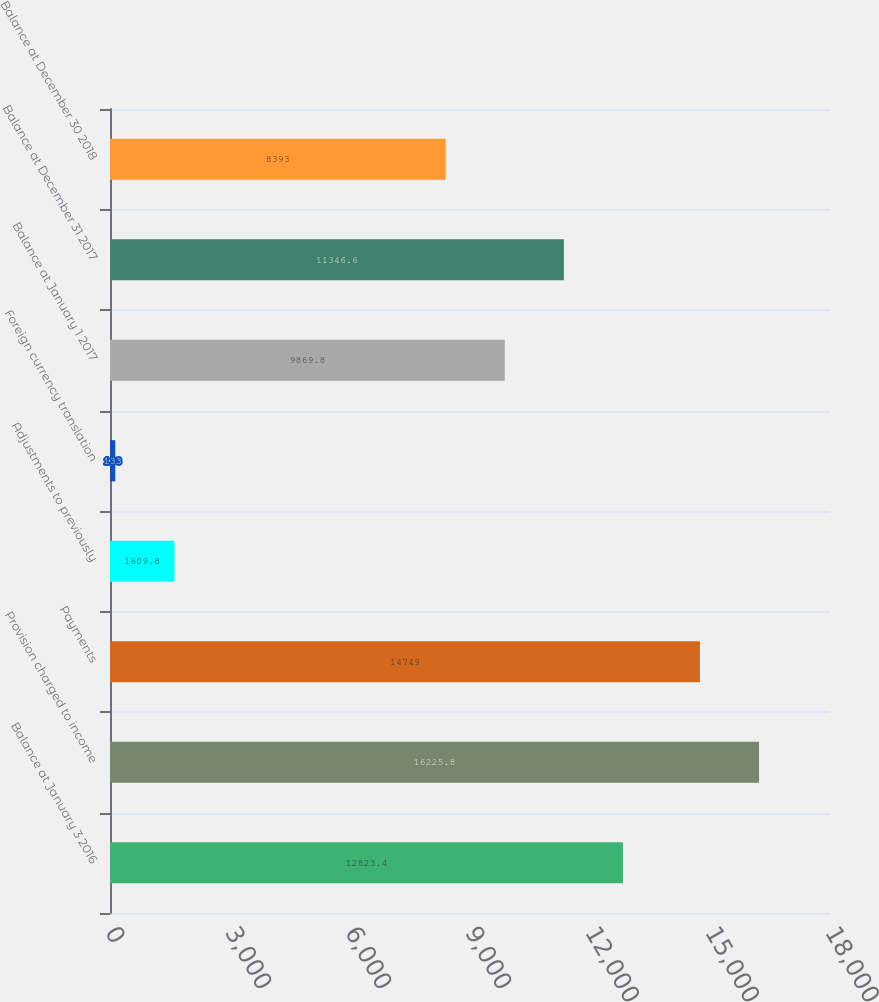Convert chart to OTSL. <chart><loc_0><loc_0><loc_500><loc_500><bar_chart><fcel>Balance at January 3 2016<fcel>Provision charged to income<fcel>Payments<fcel>Adjustments to previously<fcel>Foreign currency translation<fcel>Balance at January 1 2017<fcel>Balance at December 31 2017<fcel>Balance at December 30 2018<nl><fcel>12823.4<fcel>16225.8<fcel>14749<fcel>1609.8<fcel>133<fcel>9869.8<fcel>11346.6<fcel>8393<nl></chart> 